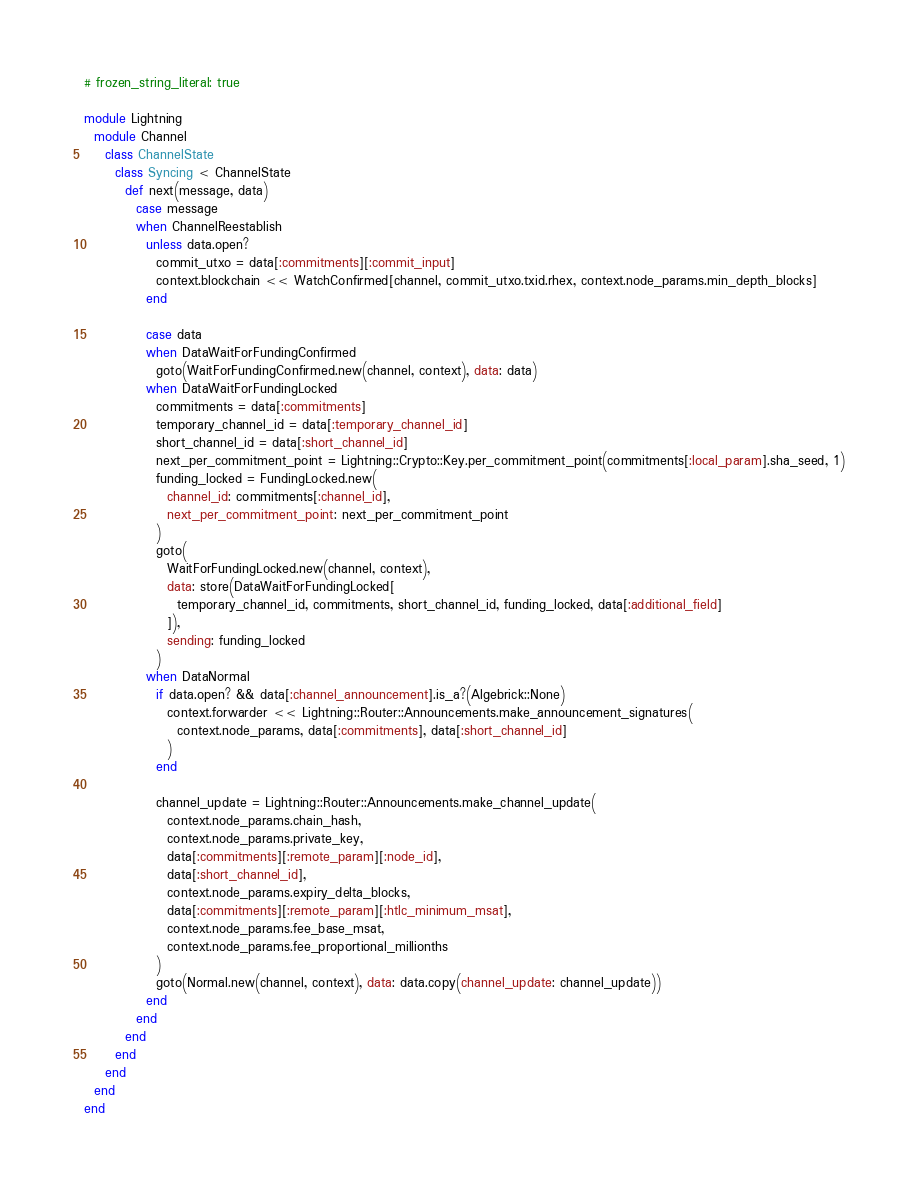Convert code to text. <code><loc_0><loc_0><loc_500><loc_500><_Ruby_># frozen_string_literal: true

module Lightning
  module Channel
    class ChannelState
      class Syncing < ChannelState
        def next(message, data)
          case message
          when ChannelReestablish
            unless data.open?
              commit_utxo = data[:commitments][:commit_input]
              context.blockchain << WatchConfirmed[channel, commit_utxo.txid.rhex, context.node_params.min_depth_blocks]
            end

            case data
            when DataWaitForFundingConfirmed
              goto(WaitForFundingConfirmed.new(channel, context), data: data)
            when DataWaitForFundingLocked
              commitments = data[:commitments]
              temporary_channel_id = data[:temporary_channel_id]
              short_channel_id = data[:short_channel_id]
              next_per_commitment_point = Lightning::Crypto::Key.per_commitment_point(commitments[:local_param].sha_seed, 1)
              funding_locked = FundingLocked.new(
                channel_id: commitments[:channel_id],
                next_per_commitment_point: next_per_commitment_point
              )
              goto(
                WaitForFundingLocked.new(channel, context),
                data: store(DataWaitForFundingLocked[
                  temporary_channel_id, commitments, short_channel_id, funding_locked, data[:additional_field]
                ]),
                sending: funding_locked
              )
            when DataNormal
              if data.open? && data[:channel_announcement].is_a?(Algebrick::None)
                context.forwarder << Lightning::Router::Announcements.make_announcement_signatures(
                  context.node_params, data[:commitments], data[:short_channel_id]
                )
              end

              channel_update = Lightning::Router::Announcements.make_channel_update(
                context.node_params.chain_hash,
                context.node_params.private_key,
                data[:commitments][:remote_param][:node_id],
                data[:short_channel_id],
                context.node_params.expiry_delta_blocks,
                data[:commitments][:remote_param][:htlc_minimum_msat],
                context.node_params.fee_base_msat,
                context.node_params.fee_proportional_millionths
              )
              goto(Normal.new(channel, context), data: data.copy(channel_update: channel_update))
            end
          end
        end
      end
    end
  end
end
</code> 